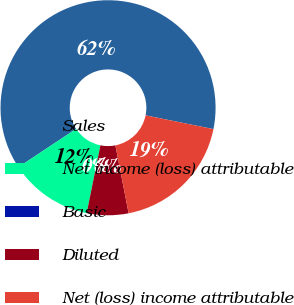Convert chart. <chart><loc_0><loc_0><loc_500><loc_500><pie_chart><fcel>Sales<fcel>Net income (loss) attributable<fcel>Basic<fcel>Diluted<fcel>Net (loss) income attributable<nl><fcel>62.5%<fcel>12.5%<fcel>0.0%<fcel>6.25%<fcel>18.75%<nl></chart> 